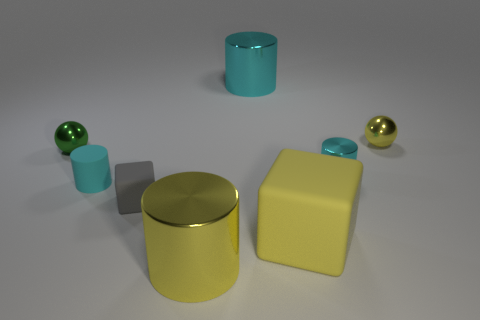Are there any rubber spheres of the same color as the matte cylinder?
Give a very brief answer. No. What is the big yellow cylinder made of?
Your answer should be compact. Metal. What number of things are either purple rubber cylinders or green metal balls?
Offer a terse response. 1. There is a cyan metallic cylinder behind the tiny yellow metallic thing; what size is it?
Give a very brief answer. Large. What number of other things are the same material as the tiny green sphere?
Make the answer very short. 4. Is there a tiny yellow shiny object behind the yellow metallic object that is behind the gray thing?
Offer a terse response. No. Is there any other thing that has the same shape as the large rubber thing?
Your answer should be compact. Yes. There is another object that is the same shape as the green shiny object; what is its color?
Make the answer very short. Yellow. The green metal thing is what size?
Keep it short and to the point. Small. Is the number of big cyan objects that are behind the large cyan shiny cylinder less than the number of green rubber balls?
Provide a short and direct response. No. 